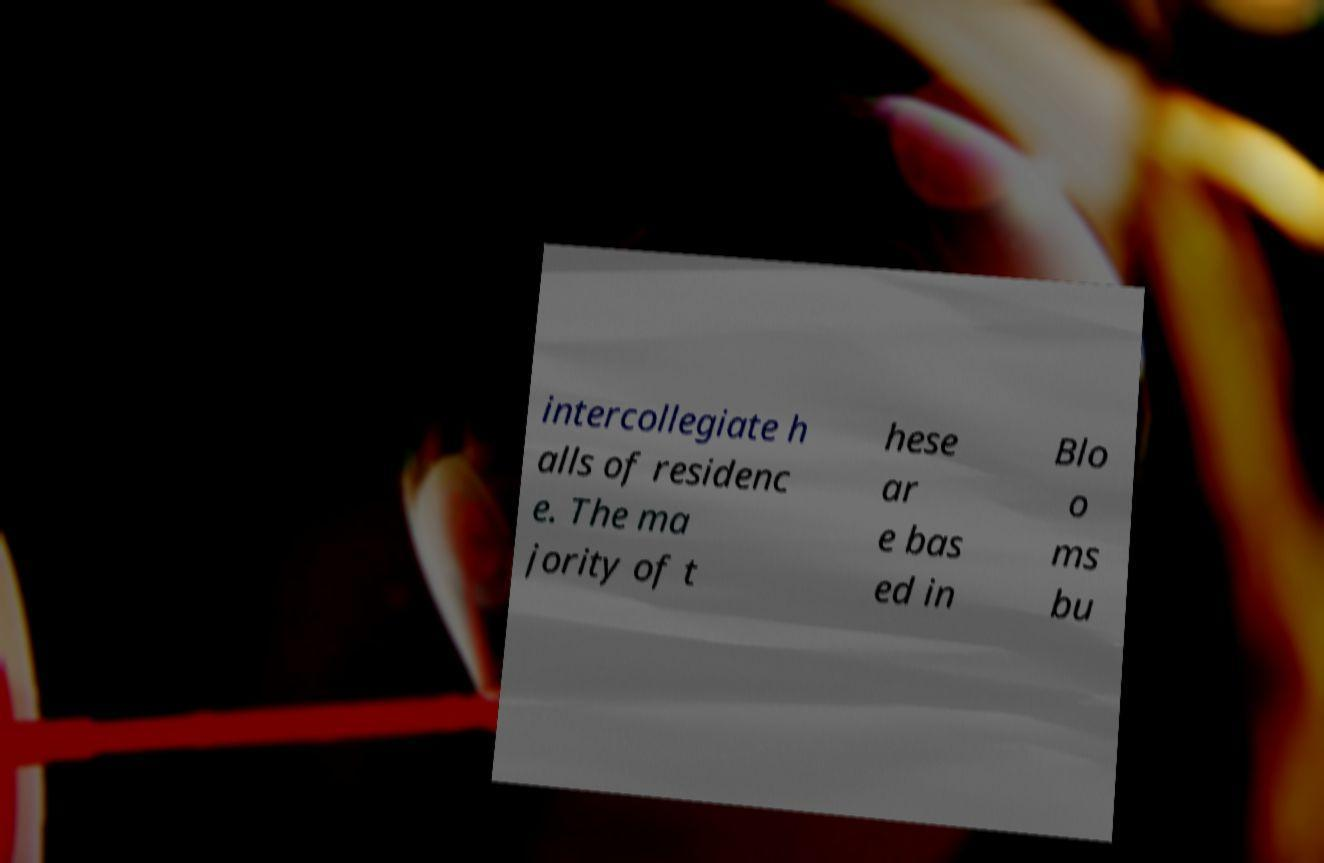Could you extract and type out the text from this image? intercollegiate h alls of residenc e. The ma jority of t hese ar e bas ed in Blo o ms bu 